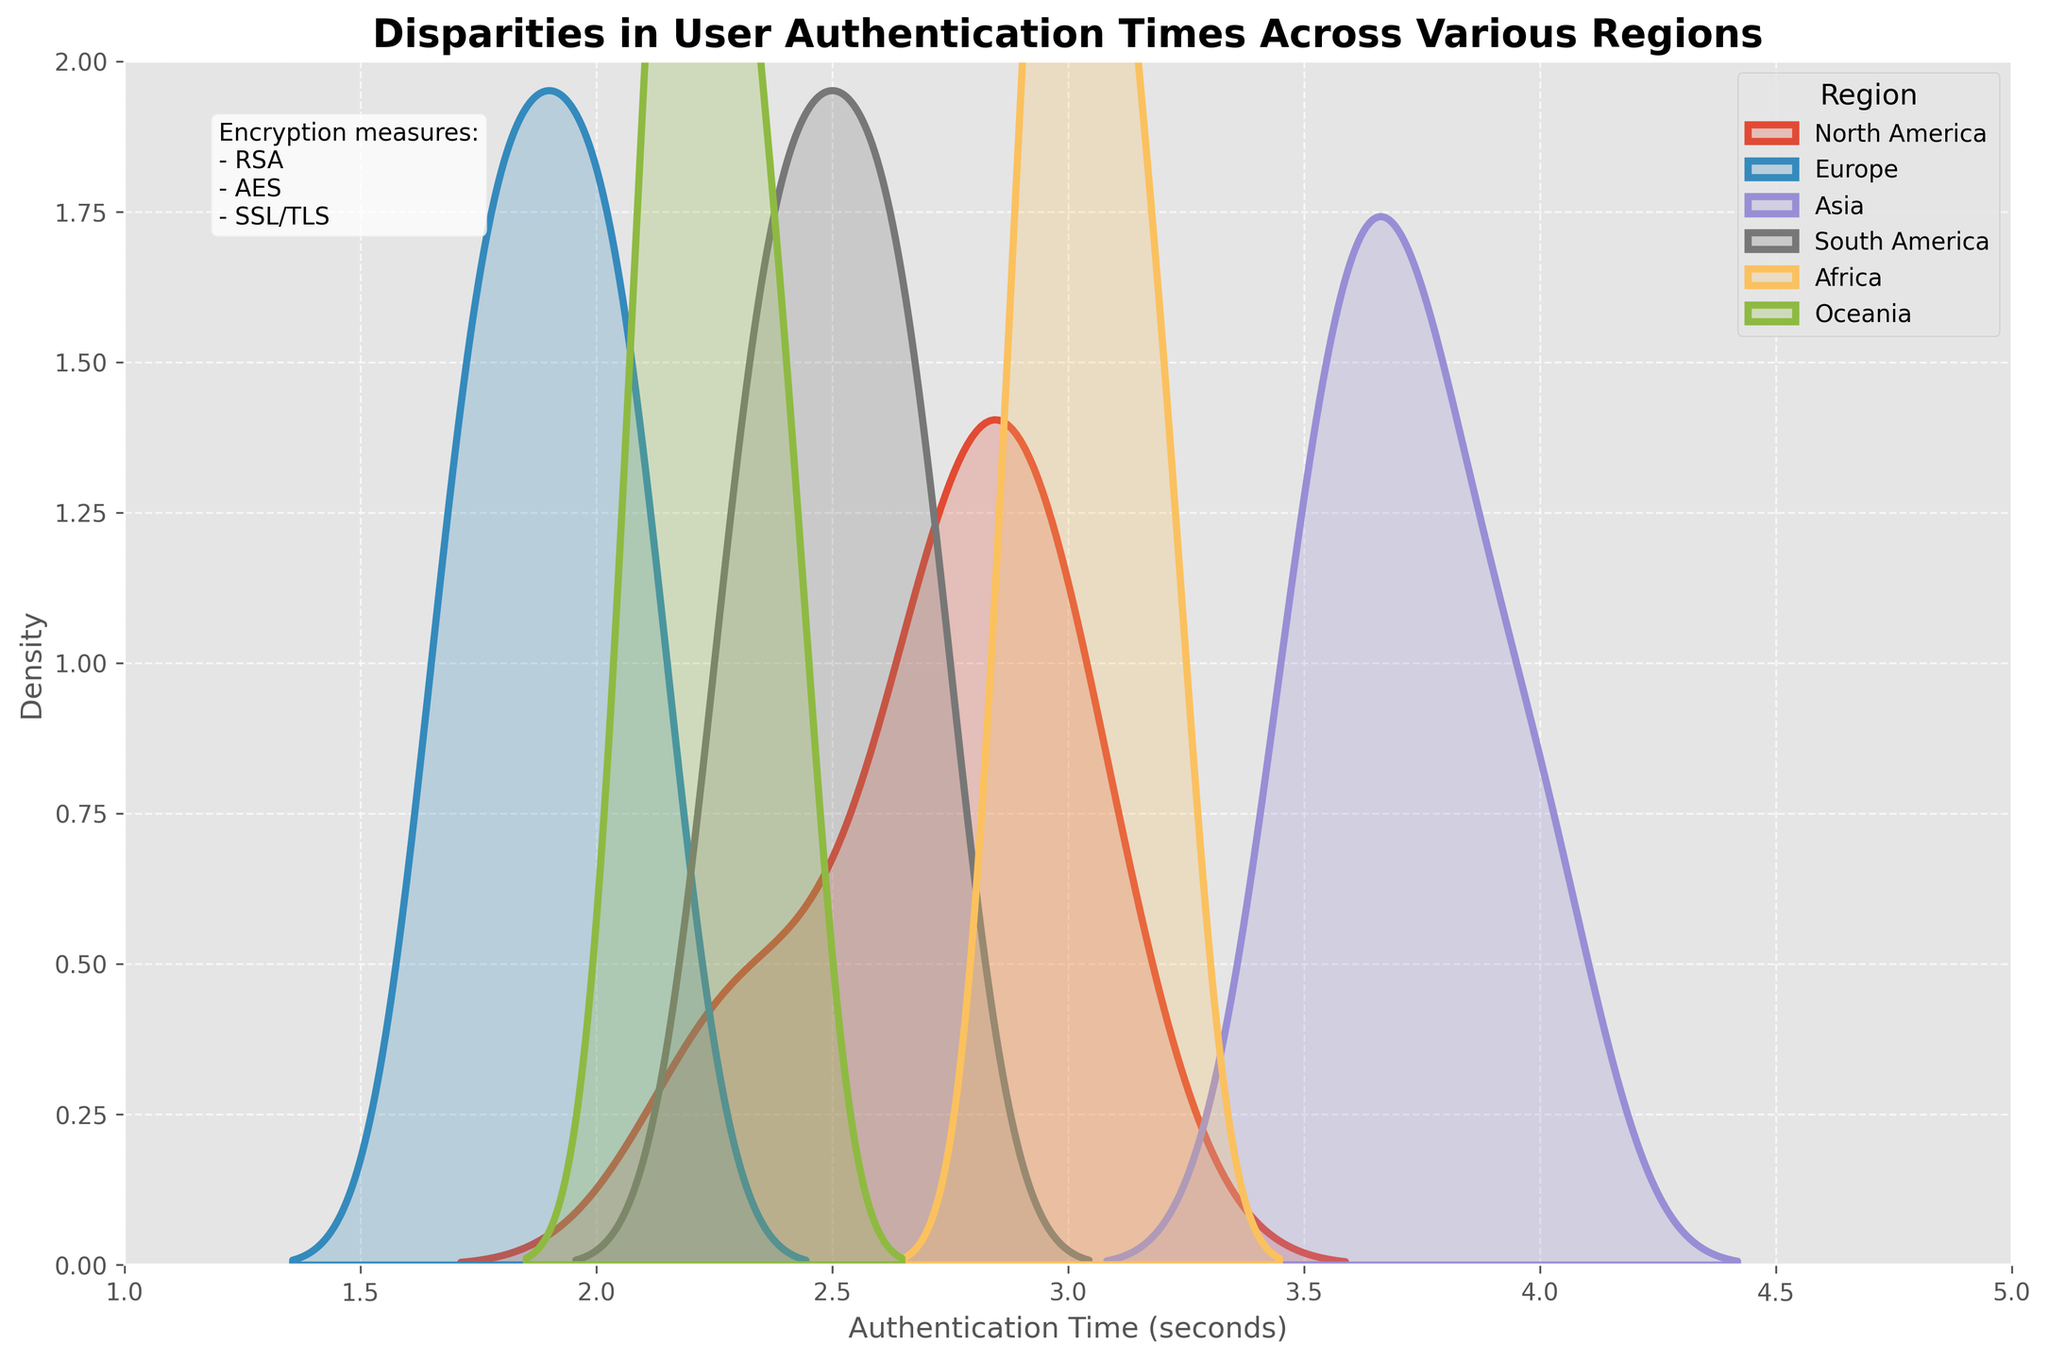What is the title of the figure? The title is usually located at the top of the figure. Here, it states "Disparities in User Authentication Times Across Various Regions".
Answer: Disparities in User Authentication Times Across Various Regions Which region has the highest density peak in the distplot? In a density plot, the peak represents where the highest density of data points lies. For Asia, the height and peak surpass those of other regions.
Answer: Asia What is the range of authentication times shown on the x-axis? The x-axis indicates the range of the data values. The x-axis labels start from 1 second and end at 5 seconds.
Answer: 1 to 5 seconds Between Europe and Africa, which region shows a wider spread of user authentication times? By comparing the width of the density curves, Europe’s curve appears narrower, indicating less spread. Africa's curve is broader in comparison.
Answer: Africa Which regions have user authentication times clustered around 3 seconds? By observing the density peaks, North America and Africa have their peaks near the 3 seconds mark.
Answer: North America and Africa How does the density of North America compare to South America? The density peak for North America is sharper and higher compared to South America, indicating a more concentrated distribution around its central value.
Answer: North American density is higher and sharper What encryption measures are mentioned in the figure's text box? The text box on the figure mentions encryption measures. It lists "RSA, AES, SSL/TLS".
Answer: RSA, AES, SSL/TLS Describe the density distribution for Oceania. The density curve for Oceania is relatively mild and centered around 2.2 seconds, with a small peak and narrow spread.
Answer: Mild, centered around 2.2 seconds In terms of authentication time density, which region shows the least variability? Least variability would be indicated by the narrowest density curve. Europe’s density curve is the narrowest and tallest, indicating the least variability.
Answer: Europe 